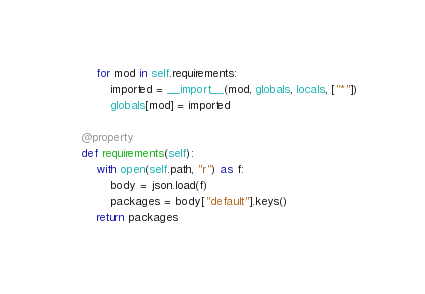<code> <loc_0><loc_0><loc_500><loc_500><_Python_>        for mod in self.requirements:
            imported = __import__(mod, globals, locals, ["*"])
            globals[mod] = imported

    @property
    def requirements(self):
        with open(self.path, "r") as f:
            body = json.load(f)
            packages = body["default"].keys()
        return packages
</code> 